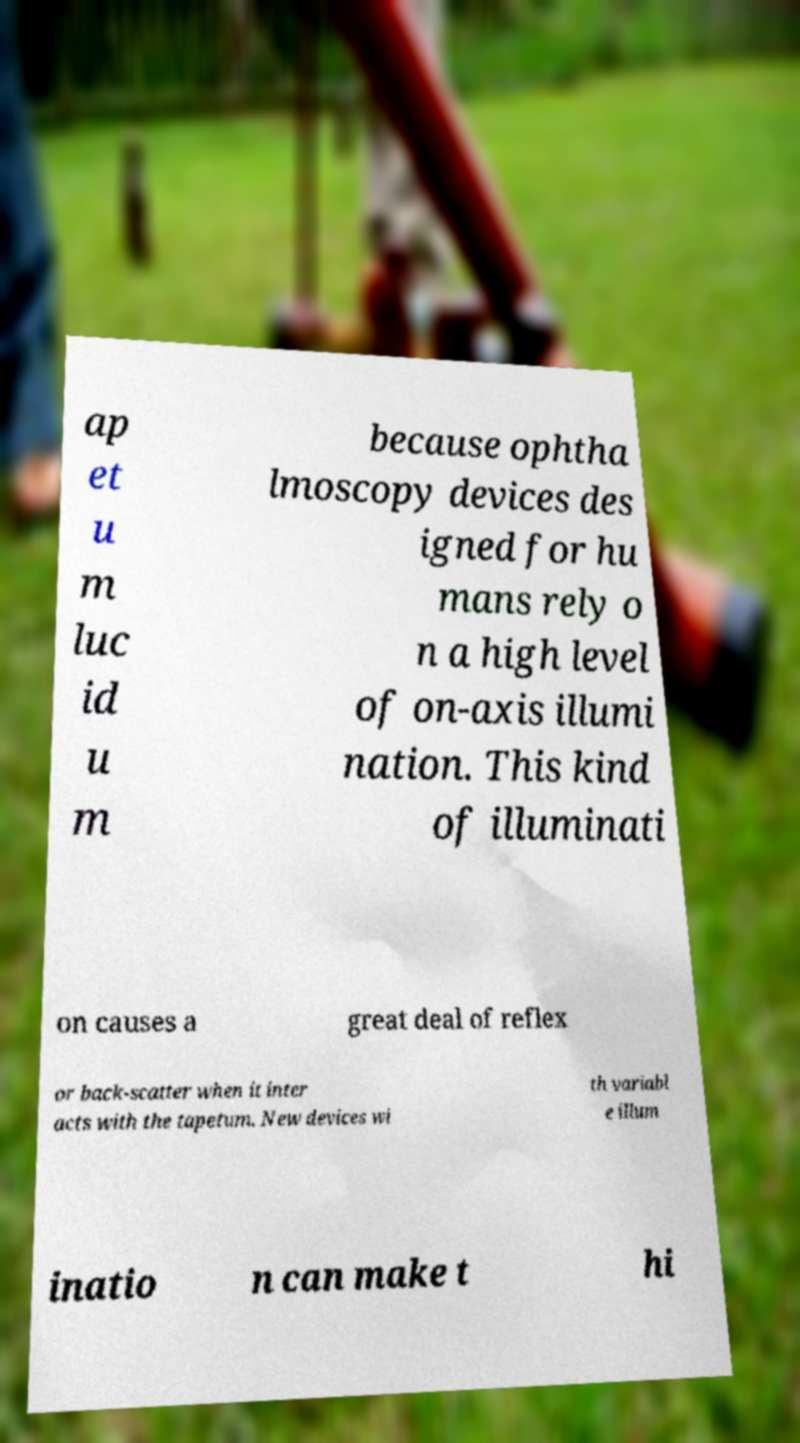What messages or text are displayed in this image? I need them in a readable, typed format. ap et u m luc id u m because ophtha lmoscopy devices des igned for hu mans rely o n a high level of on-axis illumi nation. This kind of illuminati on causes a great deal of reflex or back-scatter when it inter acts with the tapetum. New devices wi th variabl e illum inatio n can make t hi 